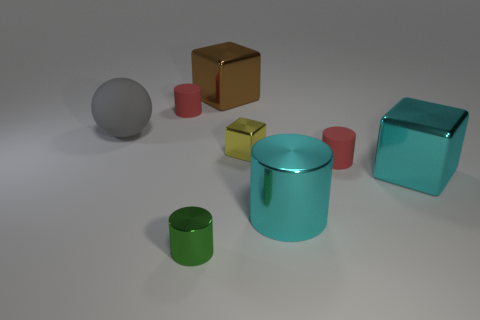Add 1 tiny green metallic things. How many objects exist? 9 Subtract all cubes. How many objects are left? 5 Add 4 cyan objects. How many cyan objects exist? 6 Subtract 0 yellow spheres. How many objects are left? 8 Subtract all large brown things. Subtract all red matte cylinders. How many objects are left? 5 Add 6 tiny green metal cylinders. How many tiny green metal cylinders are left? 7 